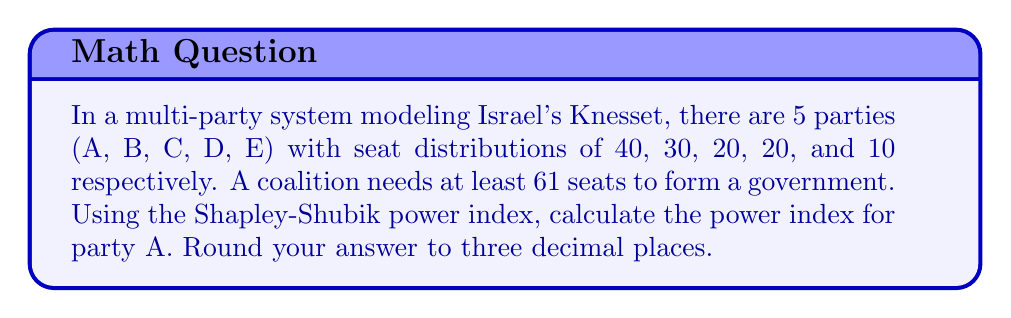Can you solve this math problem? To solve this problem, we'll use the Shapley-Shubik power index, which is a game-theoretic approach to measuring voting power in coalition formation. Here's the step-by-step process:

1) First, we need to identify all possible winning coalitions that include party A:
   ABC, ABD, ABE, ACD, ACE, ADE, ABCD, ABCE, ABDE, ACDE, ABCDE

2) For each winning coalition, we need to count the number of permutations where A is pivotal (i.e., A's addition turns a losing coalition into a winning one):

   ABC: 2! = 2 (A must be first or second)
   ABD: 2! = 2
   ABE: 2! = 2
   ACD: 2! = 2
   ACE: 2! = 2
   ADE: 2! = 2
   ABCD: 3! = 6 (A can be in any position except last)
   ABCE: 3! = 6
   ABDE: 3! = 6
   ACDE: 3! = 6
   ABCDE: 4! = 24 (A can be in any position except last)

3) Sum up all these permutations: 2 + 2 + 2 + 2 + 2 + 2 + 6 + 6 + 6 + 6 + 24 = 60

4) The total number of permutations of all parties is 5! = 120

5) The Shapley-Shubik power index for party A is:

   $$ \text{Power Index}_A = \frac{\text{Number of pivotal permutations for A}}{\text{Total number of permutations}} = \frac{60}{120} = 0.500 $$
Answer: 0.500 